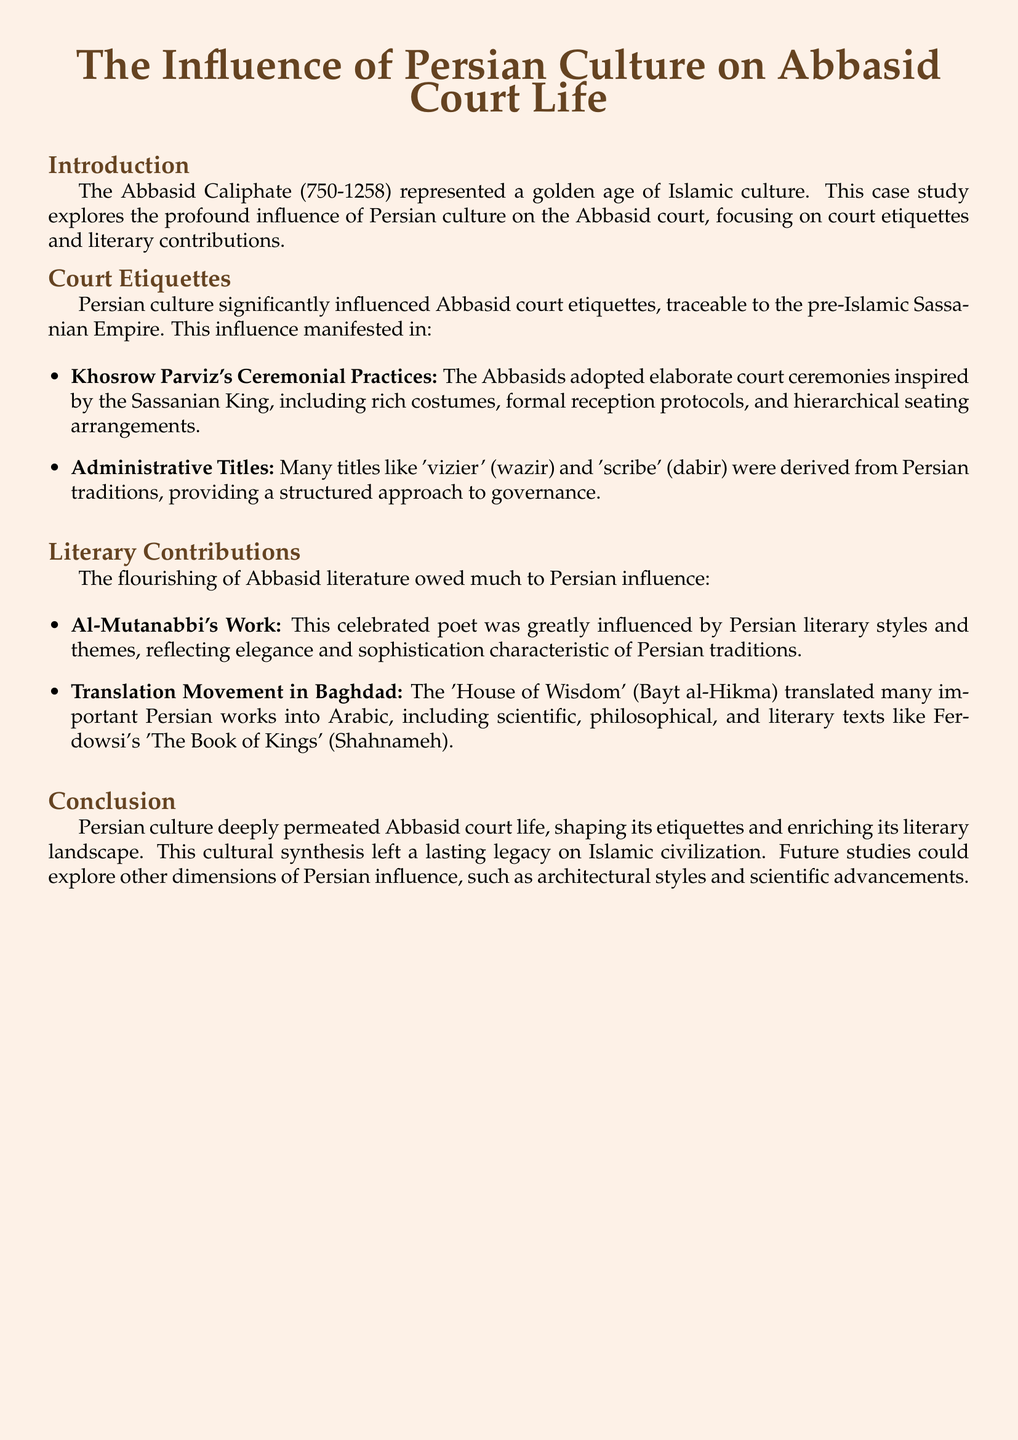what period did the Abbasid Caliphate span? The document states that the Abbasid Caliphate lasted from 750 to 1258.
Answer: 750-1258 which empire significantly influenced Abbasid court etiquettes? The influence on Abbasid court etiquettes is traced back to the pre-Islamic Sassanian Empire.
Answer: Sassanian Empire who is mentioned as a celebrated poet influenced by Persian literary styles? The document references Al-Mutanabbi as a celebrated poet influenced by Persian literature.
Answer: Al-Mutanabbi what is the name of the translation movement center in Baghdad? The document mentions the 'House of Wisdom' as the center for translation in Baghdad.
Answer: House of Wisdom what administrative title is derived from Persian traditions? The title 'vizier' is specifically mentioned as derived from Persian traditions.
Answer: vizier which Persian work was translated into Arabic according to the document? The document lists Ferdowsi's 'The Book of Kings' (Shahnameh) as an important work translated into Arabic.
Answer: Shahnameh what type of practices did the Abbasids adopt from Khosrow Parviz? The Abbasids adopted elaborate court ceremonies inspired by Khosrow Parviz.
Answer: court ceremonies what aspect of Abbasid culture did Persian influence enrich? Persian influence is said to have enriched Abbasid literature significantly.
Answer: literature what could future studies explore regarding Persian influence? Future studies could explore Persian influence on architectural styles and scientific advancements.
Answer: architectural styles and scientific advancements 